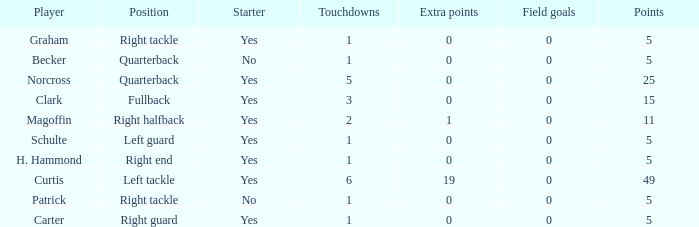Name the most touchdowns for becker  1.0. 